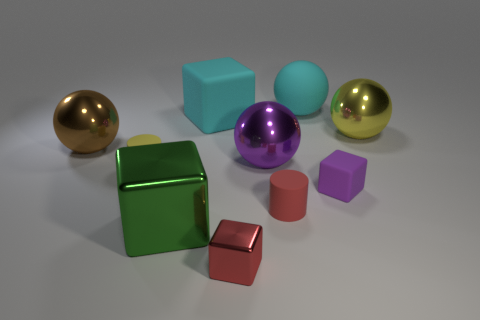What number of shiny objects are big brown things or purple things?
Offer a terse response. 2. Is there a cyan cube that has the same material as the brown object?
Your answer should be compact. No. What is the material of the green object?
Ensure brevity in your answer.  Metal. What shape is the purple thing on the left side of the rubber cube that is to the right of the red thing behind the green shiny block?
Your answer should be compact. Sphere. Are there more big shiny cubes that are in front of the yellow ball than tiny purple rubber things?
Provide a short and direct response. No. Do the big yellow metallic object and the big cyan thing that is to the left of the small metal cube have the same shape?
Provide a succinct answer. No. There is a large rubber object that is the same color as the rubber sphere; what is its shape?
Your answer should be very brief. Cube. What number of tiny matte cylinders are behind the yellow object in front of the metal thing on the left side of the tiny yellow object?
Ensure brevity in your answer.  0. There is a rubber cube that is the same size as the red metal thing; what color is it?
Offer a very short reply. Purple. How big is the yellow object on the right side of the cyan rubber sphere behind the large yellow metallic object?
Offer a very short reply. Large. 